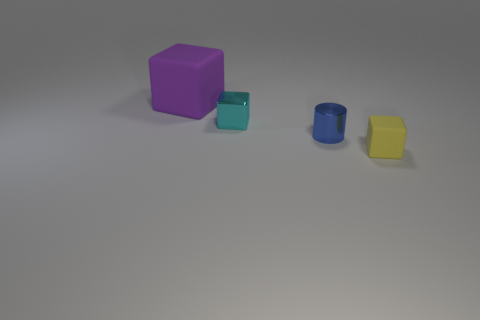Add 3 small metal blocks. How many objects exist? 7 Subtract all cylinders. How many objects are left? 3 Subtract 0 blue cubes. How many objects are left? 4 Subtract all rubber objects. Subtract all blue cylinders. How many objects are left? 1 Add 3 big rubber objects. How many big rubber objects are left? 4 Add 1 small cyan metallic objects. How many small cyan metallic objects exist? 2 